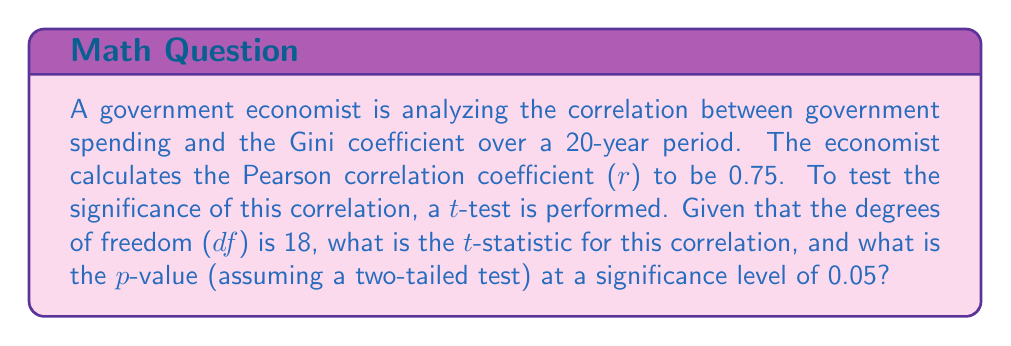Solve this math problem. To solve this problem, we'll follow these steps:

1) First, we need to calculate the t-statistic using the formula:

   $$t = \frac{r\sqrt{n-2}}{\sqrt{1-r^2}}$$

   Where:
   $r$ is the Pearson correlation coefficient
   $n$ is the sample size (which is df + 2 in this case)

2) We know:
   $r = 0.75$
   $df = 18$, so $n = 20$

3) Let's substitute these values into the formula:

   $$t = \frac{0.75\sqrt{20-2}}{\sqrt{1-0.75^2}}$$

4) Simplify:
   $$t = \frac{0.75\sqrt{18}}{\sqrt{1-0.5625}}$$
   $$t = \frac{0.75 * 4.2426}{\sqrt{0.4375}}$$
   $$t = \frac{3.1820}{0.6614}$$
   $$t \approx 4.8108$$

5) Now that we have the t-statistic, we need to find the p-value. For a two-tailed test with df = 18 and α = 0.05, the critical t-value is approximately ±2.101.

6) Since our calculated t-statistic (4.8108) is greater than the critical value, we know the p-value will be less than 0.05.

7) Using a t-distribution table or calculator, we find that the p-value for t = 4.8108 with df = 18 is approximately 0.0001.
Answer: t-statistic ≈ 4.8108, p-value ≈ 0.0001 